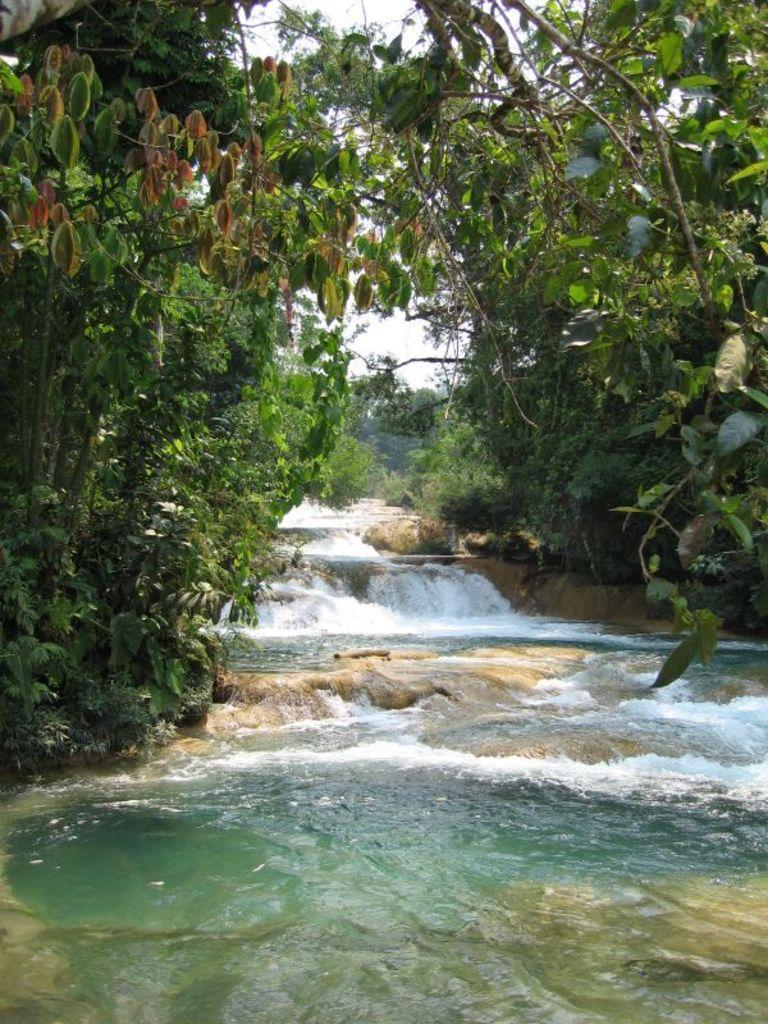In one or two sentences, can you explain what this image depicts? In this picture I can see the water in the middle, there are trees on either side of this image. In the background there is the sky. 